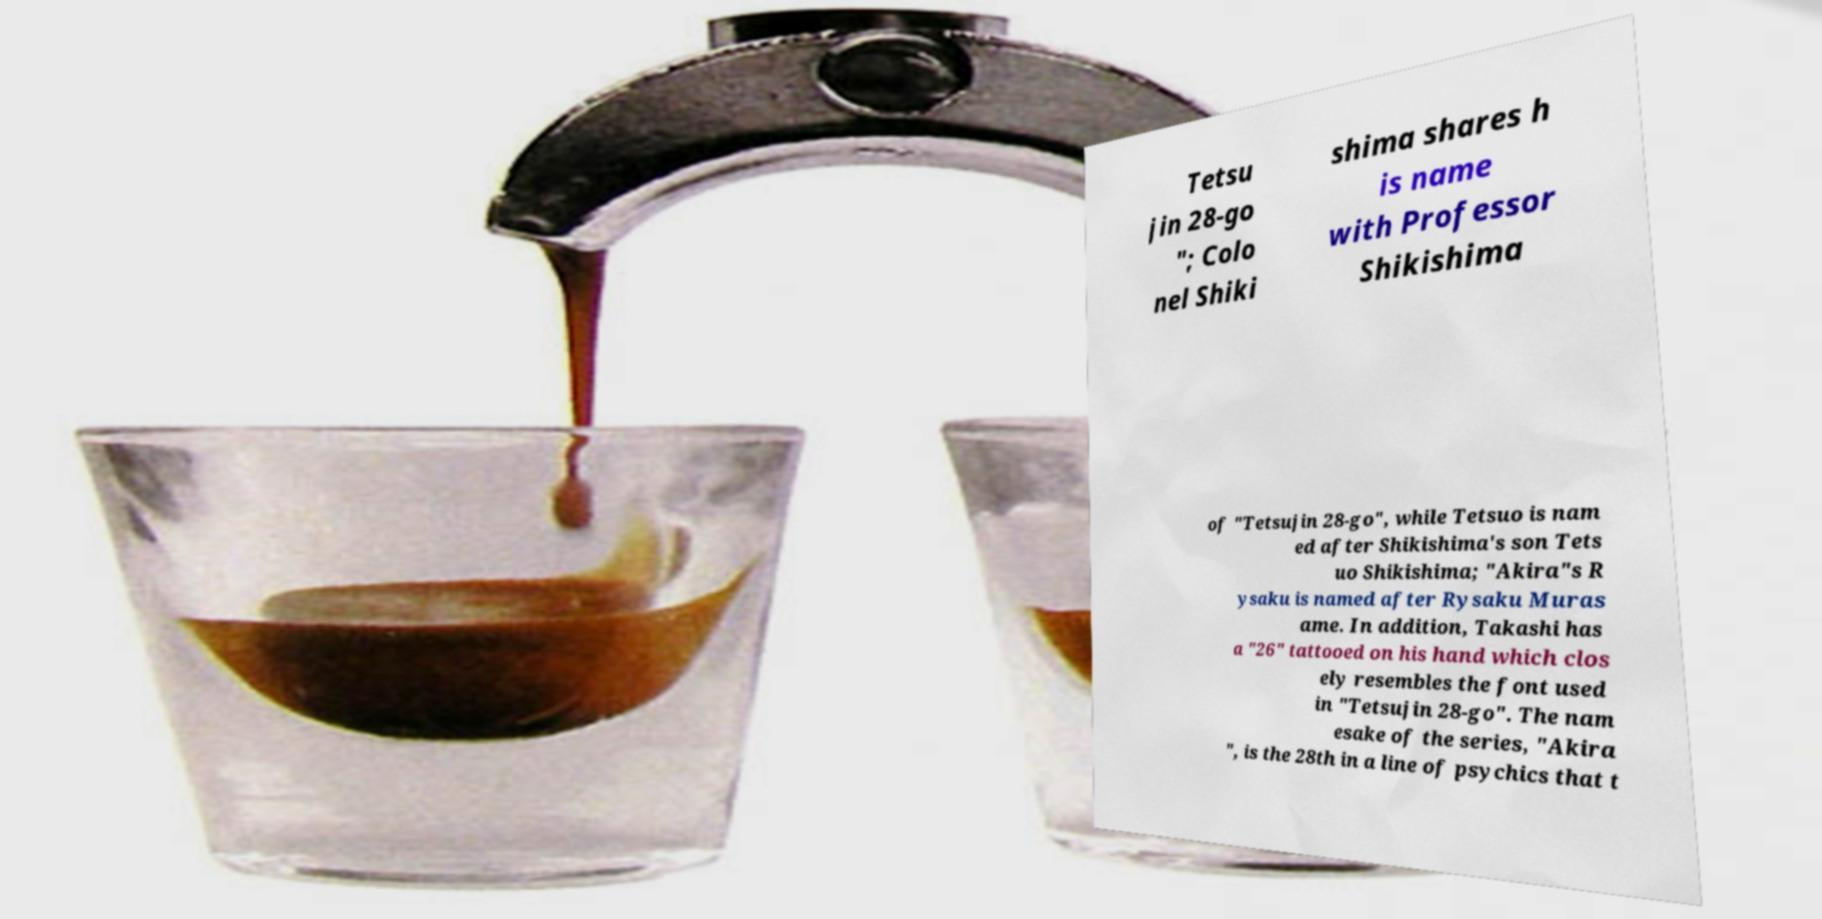I need the written content from this picture converted into text. Can you do that? Tetsu jin 28-go "; Colo nel Shiki shima shares h is name with Professor Shikishima of "Tetsujin 28-go", while Tetsuo is nam ed after Shikishima's son Tets uo Shikishima; "Akira"s R ysaku is named after Rysaku Muras ame. In addition, Takashi has a "26" tattooed on his hand which clos ely resembles the font used in "Tetsujin 28-go". The nam esake of the series, "Akira ", is the 28th in a line of psychics that t 